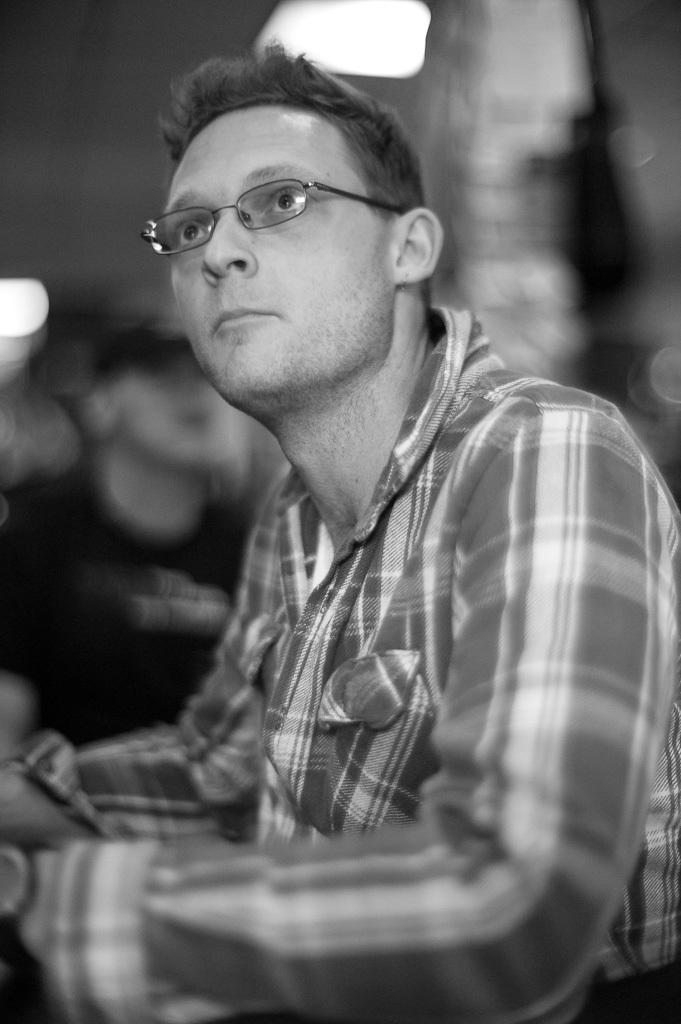Who is the main subject in the front of the image? There is a man in the front of the image. What is the man wearing in the image? The man is wearing spectacles in the image. Can you describe the background of the image? The background of the image is blurry. What is the color scheme of the image? The image is in black and white. What type of paint is the man using to create a winter scene in the image? There is no paint or winter scene present in the image; it is a black and white photograph of a man wearing spectacles. 